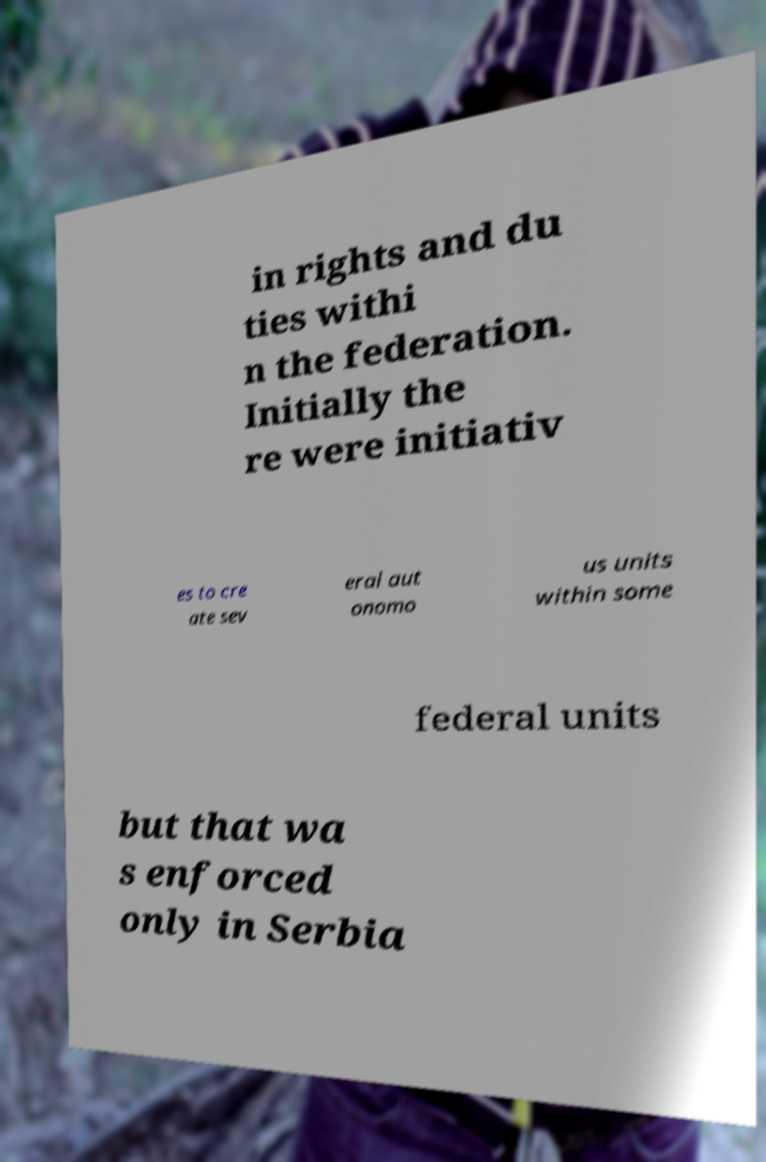Can you read and provide the text displayed in the image?This photo seems to have some interesting text. Can you extract and type it out for me? in rights and du ties withi n the federation. Initially the re were initiativ es to cre ate sev eral aut onomo us units within some federal units but that wa s enforced only in Serbia 